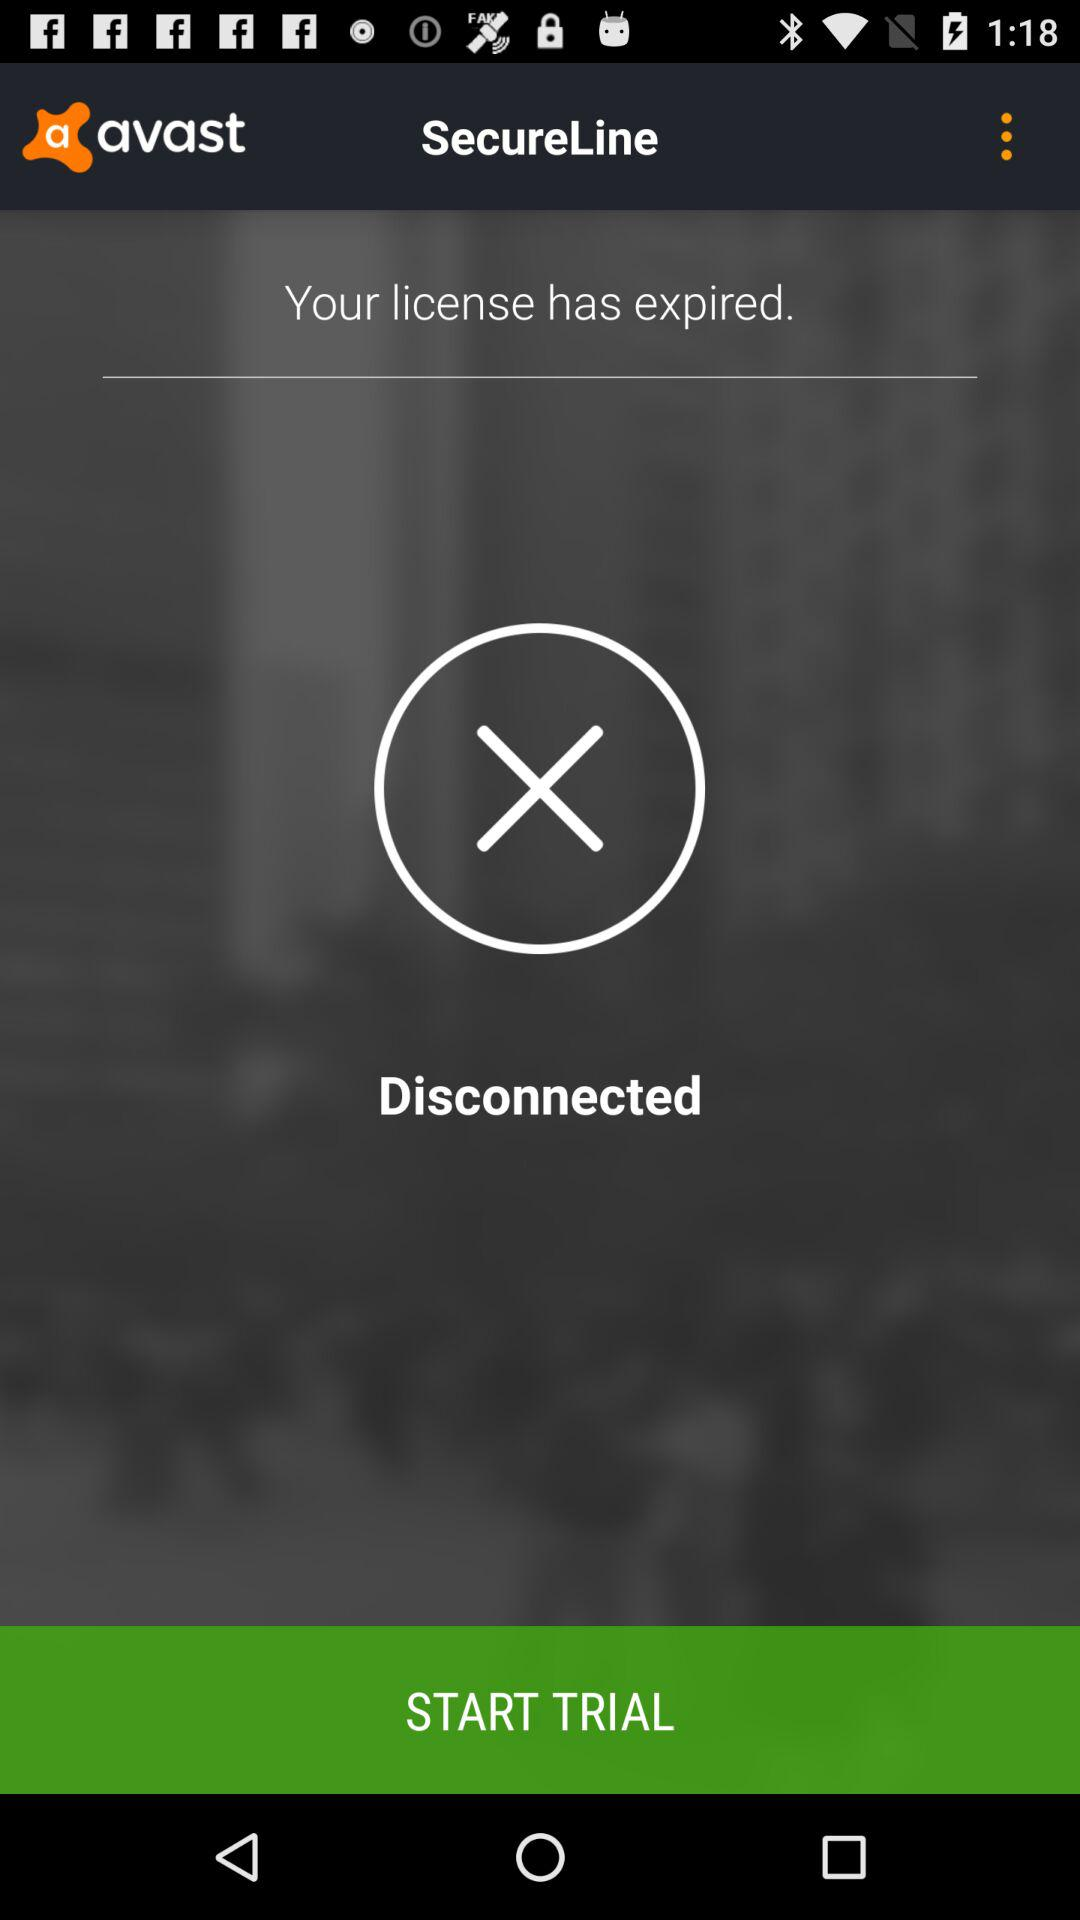What is the application name? The application name is "avast". 